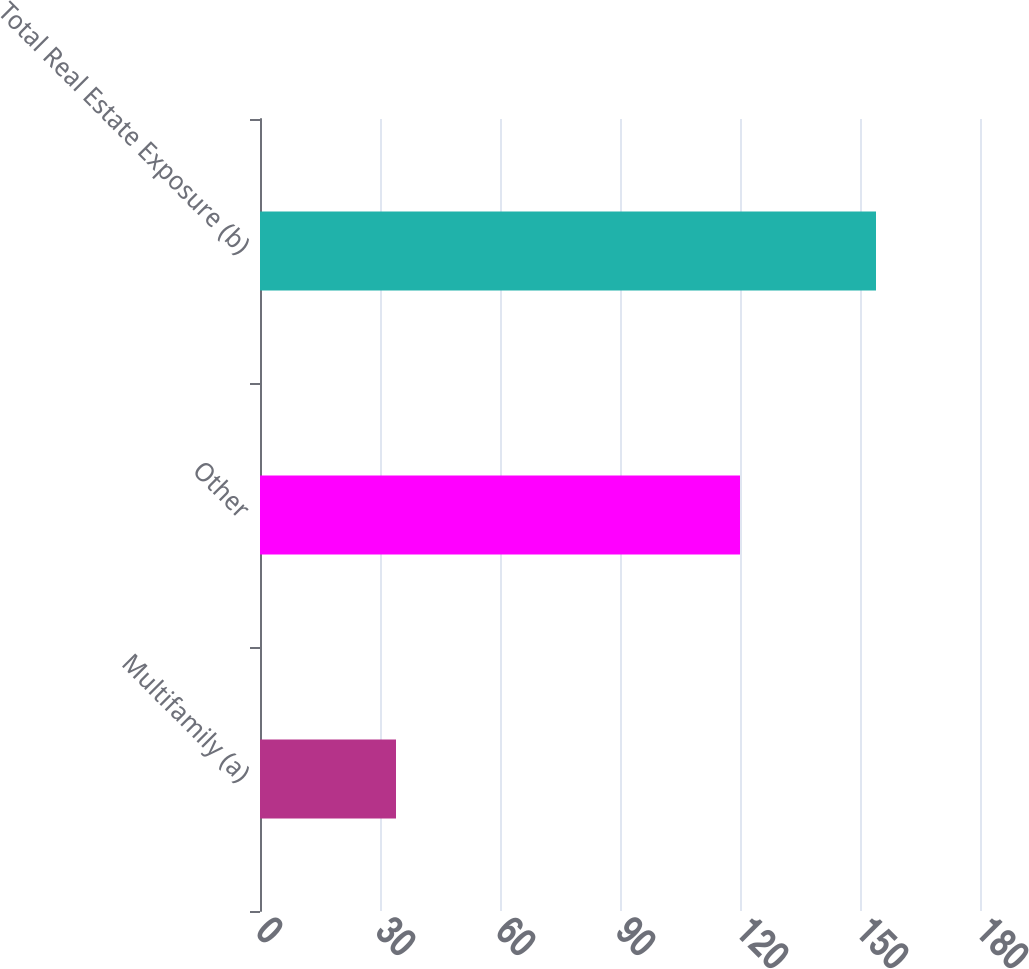Convert chart. <chart><loc_0><loc_0><loc_500><loc_500><bar_chart><fcel>Multifamily (a)<fcel>Other<fcel>Total Real Estate Exposure (b)<nl><fcel>34<fcel>120<fcel>154<nl></chart> 